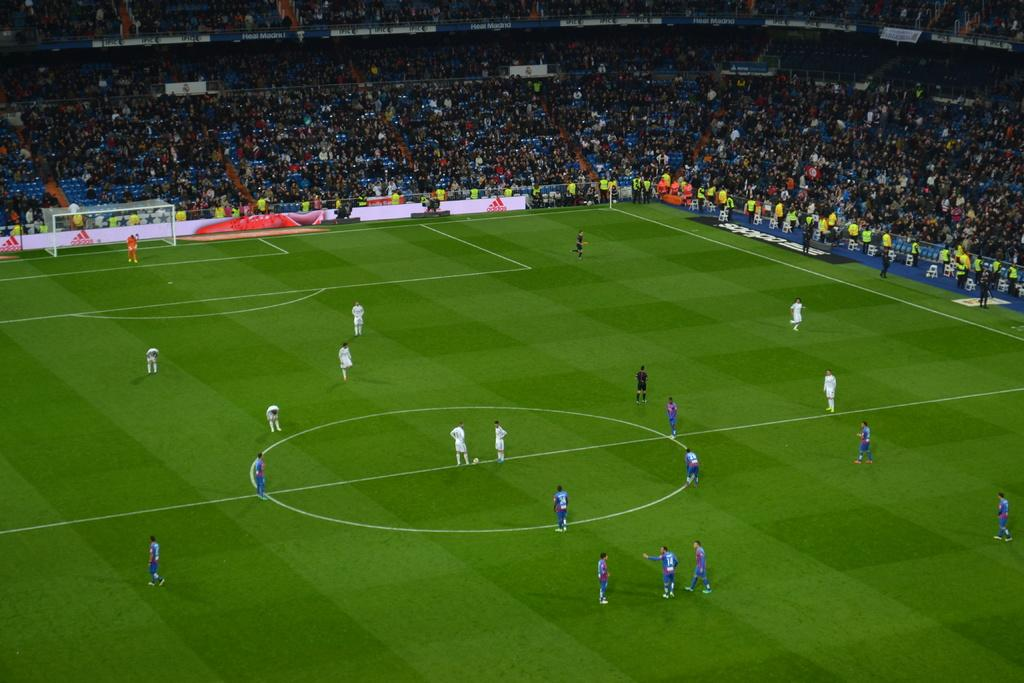What is happening in the center of the image? There are people on the ground and a ball in the center of the image. What can be seen in the background of the image? There are poles, a fence, a shed, and objects in the background of the image. Can you describe the crowd in the background? There is a crowd in the background of the image. How does the ball express its feelings of hate towards the people in the image? The ball does not express any feelings, as it is an inanimate object. What type of friction can be observed between the people and the ball in the image? There is no friction mentioned or observable in the image; it simply shows people and a ball in the center. 